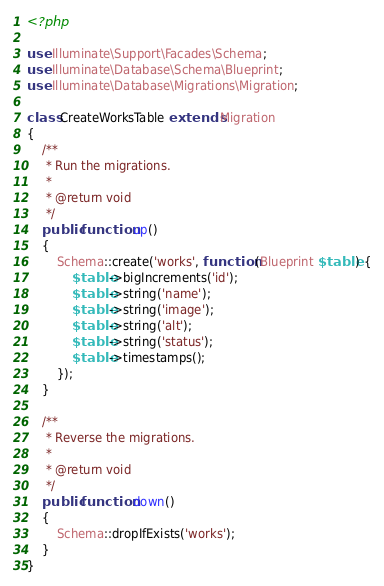Convert code to text. <code><loc_0><loc_0><loc_500><loc_500><_PHP_><?php

use Illuminate\Support\Facades\Schema;
use Illuminate\Database\Schema\Blueprint;
use Illuminate\Database\Migrations\Migration;

class CreateWorksTable extends Migration
{
    /**
     * Run the migrations.
     *
     * @return void
     */
    public function up()
    {
        Schema::create('works', function (Blueprint $table) {
            $table->bigIncrements('id');
            $table->string('name');
            $table->string('image');
            $table->string('alt');
            $table->string('status');
            $table->timestamps();
        });
    }

    /**
     * Reverse the migrations.
     *
     * @return void
     */
    public function down()
    {
        Schema::dropIfExists('works');
    }
}
</code> 